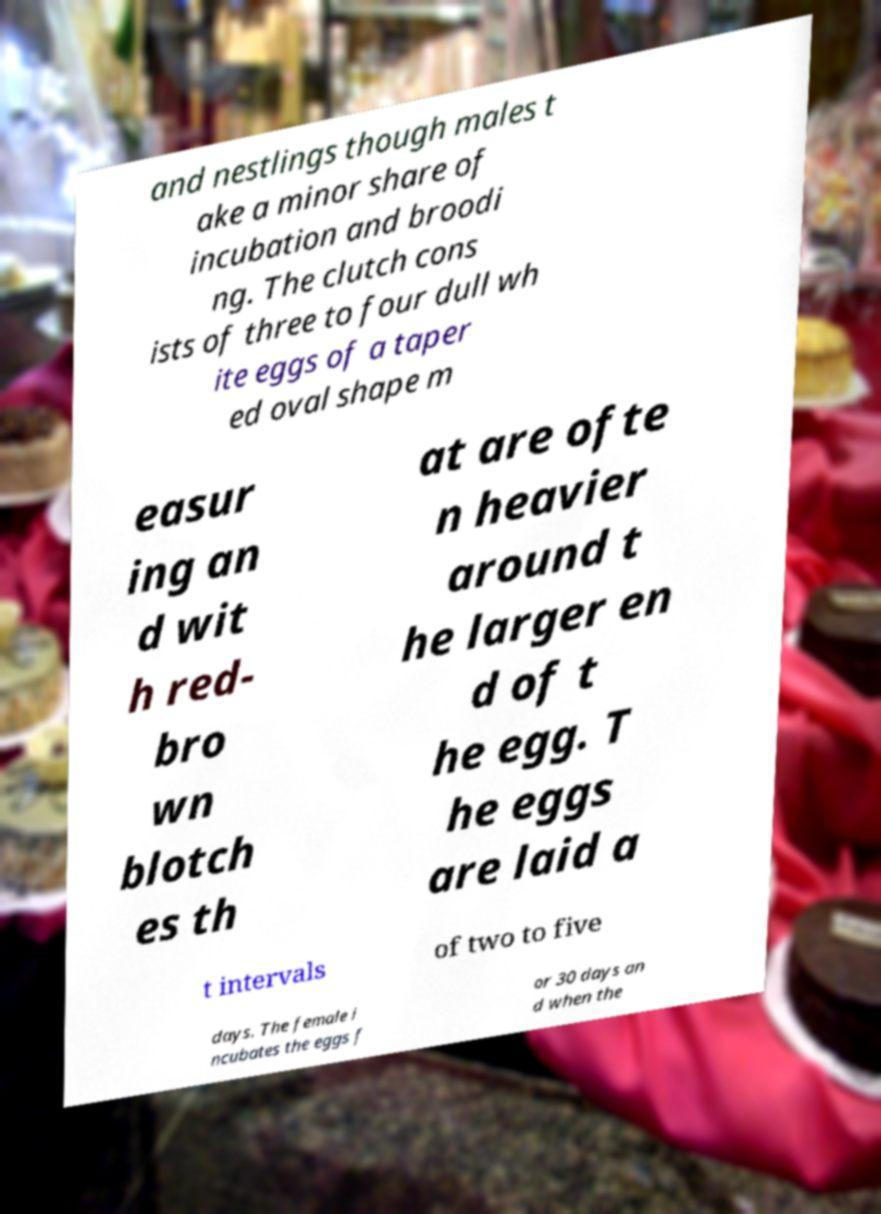Please read and relay the text visible in this image. What does it say? and nestlings though males t ake a minor share of incubation and broodi ng. The clutch cons ists of three to four dull wh ite eggs of a taper ed oval shape m easur ing an d wit h red- bro wn blotch es th at are ofte n heavier around t he larger en d of t he egg. T he eggs are laid a t intervals of two to five days. The female i ncubates the eggs f or 30 days an d when the 